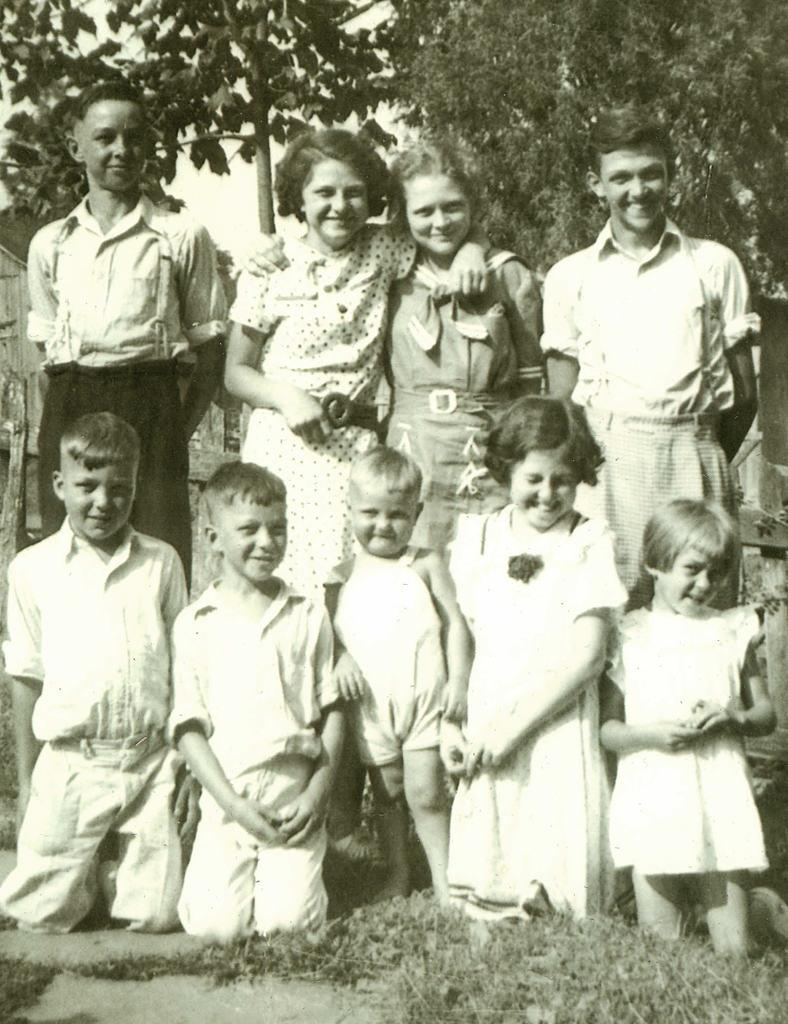What type of vegetation is present in the image? There is grass in the image. What can be seen in the foreground of the image? There is a group of people in the front of the image. What is visible in the background of the image? There are trees in the background of the image. What theory is being discussed by the group of people in the image? There is no indication in the image of a theory being discussed; the group of people is not engaged in any visible conversation or activity. 